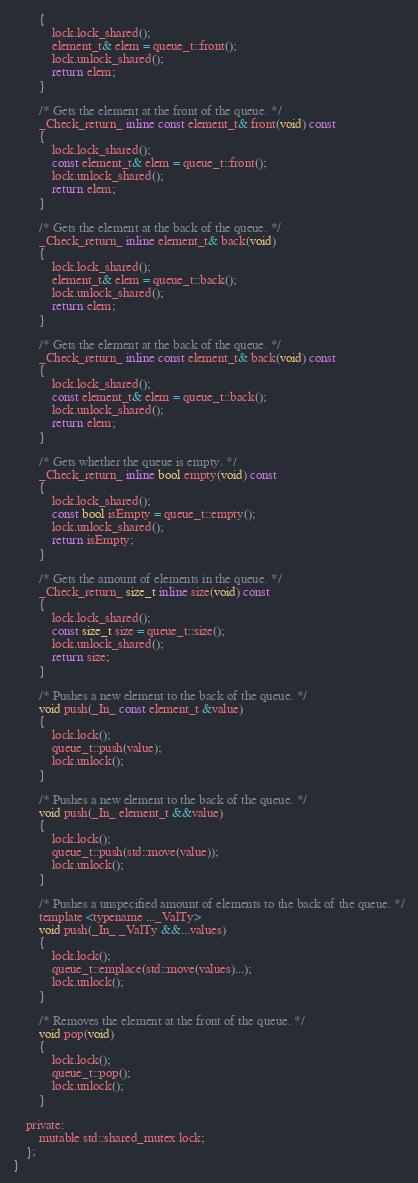<code> <loc_0><loc_0><loc_500><loc_500><_C_>		{
			lock.lock_shared();
			element_t& elem = queue_t::front();
			lock.unlock_shared();
			return elem;
		}

		/* Gets the element at the front of the queue. */
		_Check_return_ inline const element_t& front(void) const
		{
			lock.lock_shared();
			const element_t& elem = queue_t::front();
			lock.unlock_shared();
			return elem;
		}

		/* Gets the element at the back of the queue. */
		_Check_return_ inline element_t& back(void)
		{
			lock.lock_shared();
			element_t& elem = queue_t::back();
			lock.unlock_shared();
			return elem;
		}

		/* Gets the element at the back of the queue. */
		_Check_return_ inline const element_t& back(void) const
		{
			lock.lock_shared();
			const element_t& elem = queue_t::back();
			lock.unlock_shared();
			return elem;
		}

		/* Gets whether the queue is empty. */
		_Check_return_ inline bool empty(void) const
		{
			lock.lock_shared();
			const bool isEmpty = queue_t::empty();
			lock.unlock_shared();
			return isEmpty;
		}

		/* Gets the amount of elements in the queue. */
		_Check_return_ size_t inline size(void) const
		{
			lock.lock_shared();
			const size_t size = queue_t::size();
			lock.unlock_shared();
			return size;
		}

		/* Pushes a new element to the back of the queue. */
		void push(_In_ const element_t &value)
		{
			lock.lock();
			queue_t::push(value);
			lock.unlock();
		}

		/* Pushes a new element to the back of the queue. */
		void push(_In_ element_t &&value)
		{
			lock.lock();
			queue_t::push(std::move(value));
			lock.unlock();
		}

		/* Pushes a unspecified amount of elements to the back of the queue. */
		template <typename ..._ValTy>
		void push(_In_ _ValTy &&...values)
		{
			lock.lock();
			queue_t::emplace(std::move(values)...);
			lock.unlock();
		}

		/* Removes the element at the front of the queue. */
		void pop(void)
		{
			lock.lock();
			queue_t::pop();
			lock.unlock();
		}

	private: 
		mutable std::shared_mutex lock;
	};
}</code> 